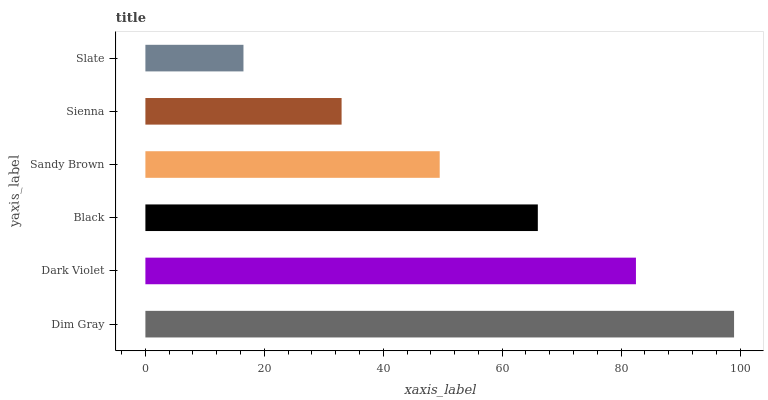Is Slate the minimum?
Answer yes or no. Yes. Is Dim Gray the maximum?
Answer yes or no. Yes. Is Dark Violet the minimum?
Answer yes or no. No. Is Dark Violet the maximum?
Answer yes or no. No. Is Dim Gray greater than Dark Violet?
Answer yes or no. Yes. Is Dark Violet less than Dim Gray?
Answer yes or no. Yes. Is Dark Violet greater than Dim Gray?
Answer yes or no. No. Is Dim Gray less than Dark Violet?
Answer yes or no. No. Is Black the high median?
Answer yes or no. Yes. Is Sandy Brown the low median?
Answer yes or no. Yes. Is Sienna the high median?
Answer yes or no. No. Is Dim Gray the low median?
Answer yes or no. No. 